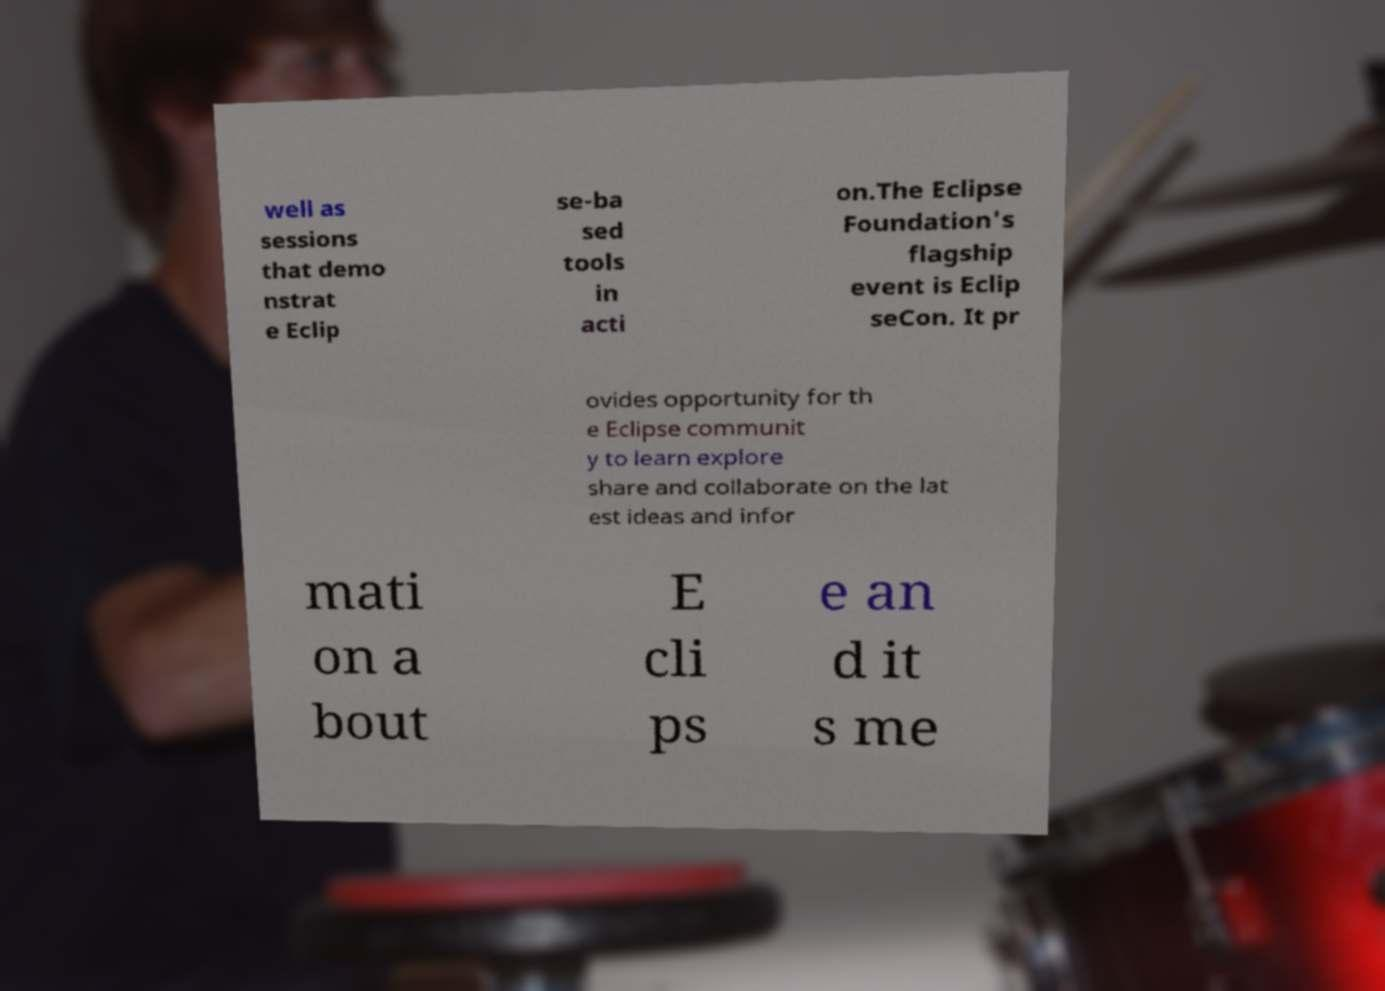I need the written content from this picture converted into text. Can you do that? well as sessions that demo nstrat e Eclip se-ba sed tools in acti on.The Eclipse Foundation's flagship event is Eclip seCon. It pr ovides opportunity for th e Eclipse communit y to learn explore share and collaborate on the lat est ideas and infor mati on a bout E cli ps e an d it s me 